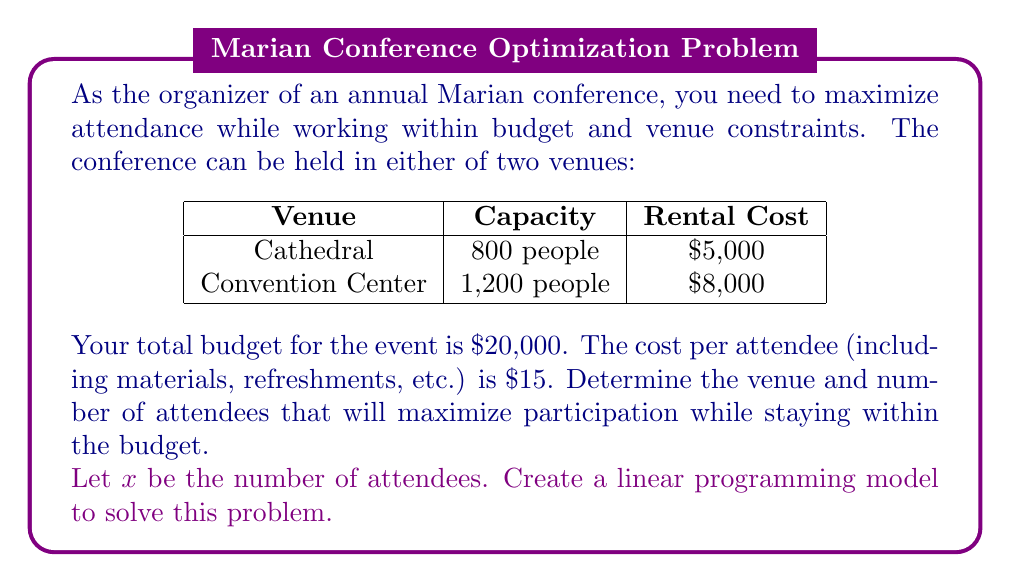Solve this math problem. To solve this optimization problem, we'll follow these steps:

1. Define the objective function
2. Identify the constraints
3. Set up the linear programming model
4. Solve the model for both venues
5. Compare the results and choose the optimal solution

Step 1: Define the objective function
Our goal is to maximize the number of attendees, so our objective function is simply:
Maximize $x$

Step 2: Identify the constraints
We have two main constraints:
a) Budget constraint: Total cost ≤ $20,000
b) Capacity constraint: Number of attendees ≤ Venue capacity

Step 3: Set up the linear programming model
We need to create two separate models, one for each venue:

For the cathedral:
Maximize $x$
Subject to:
$5000 + 15x ≤ 20000$ (Budget constraint)
$x ≤ 800$ (Capacity constraint)
$x ≥ 0$ (Non-negativity constraint)

For the convention center:
Maximize $x$
Subject to:
$8000 + 15x ≤ 20000$ (Budget constraint)
$x ≤ 1200$ (Capacity constraint)
$x ≥ 0$ (Non-negativity constraint)

Step 4: Solve the models

For the cathedral:
From the budget constraint: $5000 + 15x ≤ 20000$
$15x ≤ 15000$
$x ≤ 1000$
The binding constraint is the capacity constraint, so $x = 800$

For the convention center:
From the budget constraint: $8000 + 15x ≤ 20000$
$15x ≤ 12000$
$x ≤ 800$
The binding constraint is the budget constraint, so $x = 800$

Step 5: Compare results
Both venues allow for a maximum of 800 attendees. However, the cathedral has a lower rental cost, which means more of the budget can be allocated to other conference expenses.

Therefore, the optimal solution is to choose the cathedral and host 800 attendees.
Answer: Choose the cathedral and host 800 attendees. 